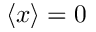<formula> <loc_0><loc_0><loc_500><loc_500>\langle x \rangle = 0</formula> 